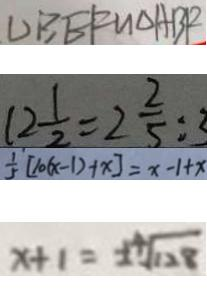Convert formula to latex. <formula><loc_0><loc_0><loc_500><loc_500>\Delta B E F \sim \Delta A B F 
 1 2 \frac { 1 } { 2 } = 2 \frac { 2 } { 5 } : 3 
 \frac { 1 } { 5 } [ 1 0 ( x - 1 ) + x ] = x - 1 + x 
 x + 1 = \pm \sqrt [ 4 ] { 1 2 8 }</formula> 